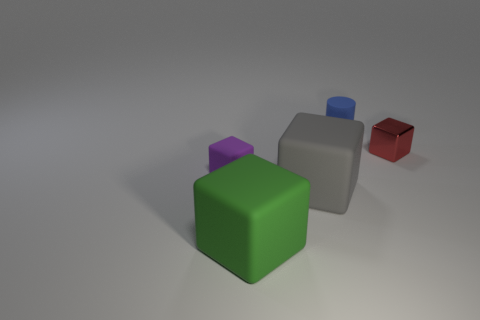What number of yellow shiny cubes are there? There are no yellow shiny cubes in the image. The cubes present are green, purple, gray, blue, and red. 